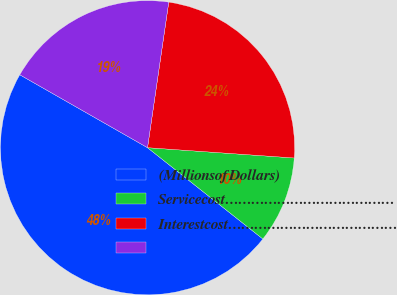Convert chart. <chart><loc_0><loc_0><loc_500><loc_500><pie_chart><fcel>(MillionsofDollars)<fcel>Servicecost…………………………………<fcel>Interestcost…………………………………<fcel>Unnamed: 3<nl><fcel>47.6%<fcel>9.54%<fcel>23.81%<fcel>19.05%<nl></chart> 